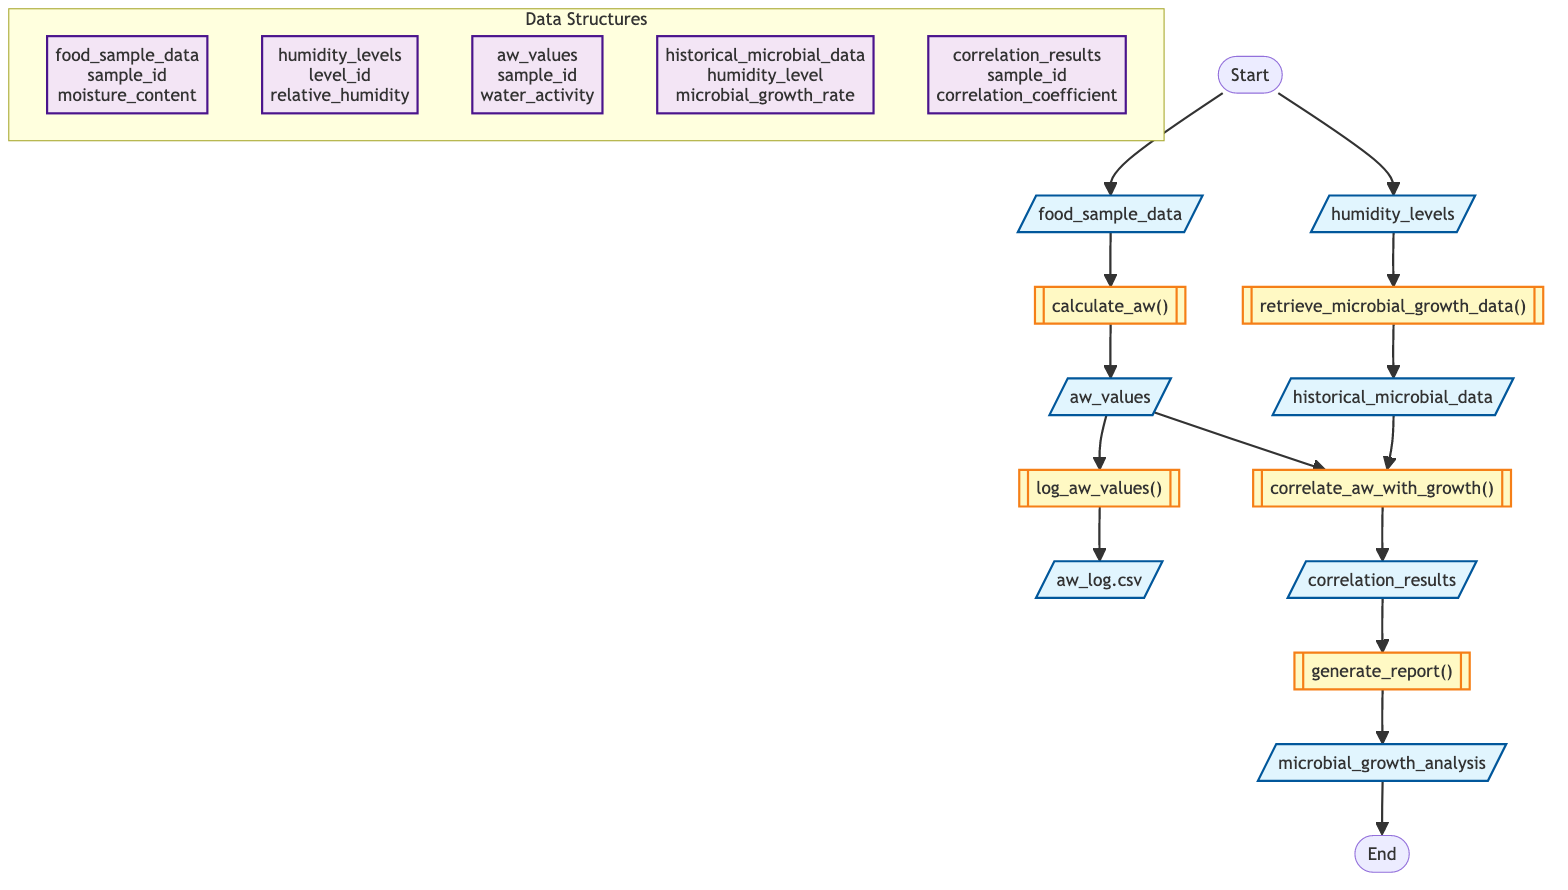What is the first input required by the function? The first input node in the diagram is labeled "food_sample_data," indicating that this is the initial input needed for the function.
Answer: food_sample_data What is the output of the function? The final output node of the flowchart is labeled "microbial_growth_analysis," which indicates that this is the end result of the function's processing.
Answer: microbial_growth_analysis How many process steps are there in the diagram? There are five process steps listed in the diagram: calculating water activity, logging water activity values, retrieving microbial growth data, correlating water activity with growth, and generating a report.
Answer: 5 What is logged into a CSV file? The process labeled "log_aw_values()" outputs "aw_log.csv" which indicates that the water activity values are logged into this CSV file.
Answer: aw_log.csv Which data structure contains the sample ID and moisture content? The data structure named "food_sample_data" includes the fields "sample_id" and "moisture_content," confirming that it contains these specific details.
Answer: food_sample_data What happens after the water activity values are calculated? After the "calculate_aw()" step, the diagram shows that the next step is to log these values, specifically through the "log_aw_values()" process.
Answer: log_aw_values() What inputs are required for the "correlate_aw_with_growth" step? This process takes two inputs: "aw_values" and "historical_microbial_data," which are both necessary to correlate water activity with microbial growth.
Answer: aw_values, historical_microbial_data What is the relationship between "aw_values" and "historical_microbial_data"? The arrow connecting "aw_values" and "historical_microbial_data" to "correlate_aw_with_growth" shows that both are required inputs for this process, indicating a direct connection for analysis.
Answer: Correlation How many nodes are there in total? By counting all the input, process, data structure, and output nodes in the diagram, including the start and end nodes, we find a total of twelve nodes.
Answer: 12 Which step follows the "retrieve_microbial_growth_data" action? The "retrieve_microbial_growth_data()" process is directly followed by the output node "historical_microbial_data," indicating that this is the data retrieved after this action.
Answer: historical_microbial_data 